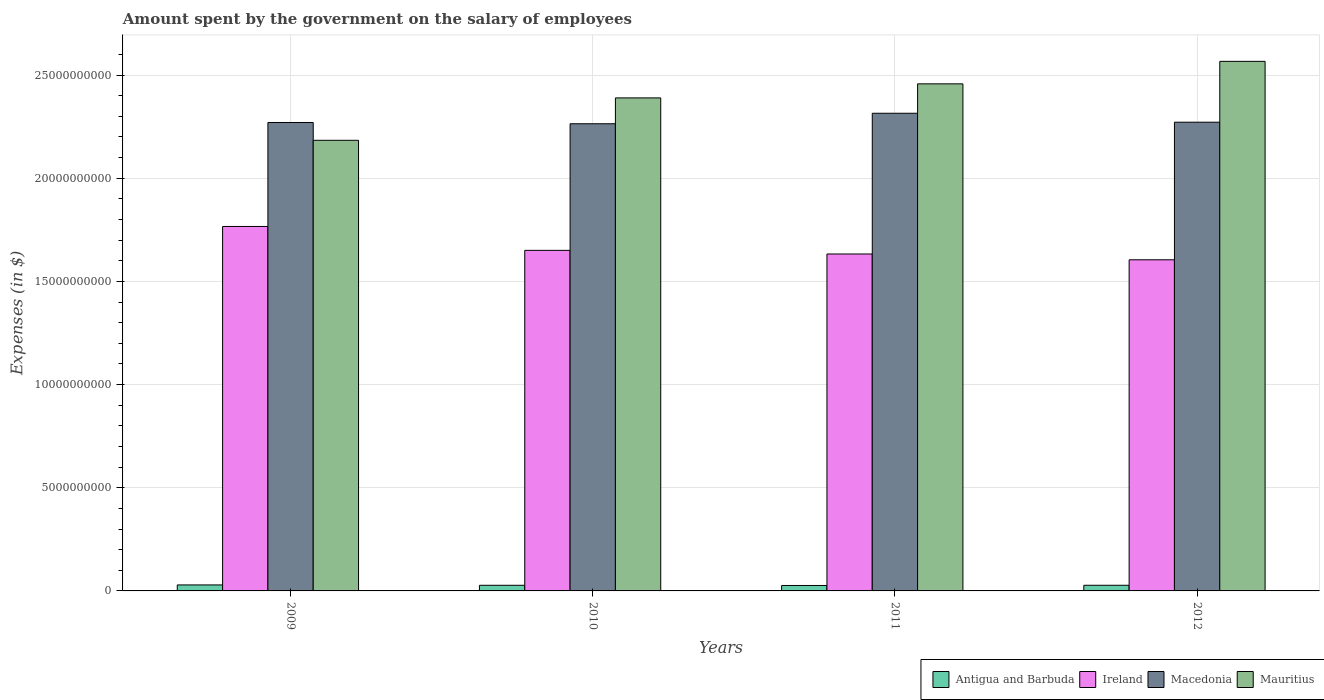Are the number of bars per tick equal to the number of legend labels?
Your response must be concise. Yes. How many bars are there on the 2nd tick from the left?
Ensure brevity in your answer.  4. How many bars are there on the 4th tick from the right?
Provide a succinct answer. 4. What is the label of the 4th group of bars from the left?
Make the answer very short. 2012. What is the amount spent on the salary of employees by the government in Mauritius in 2010?
Ensure brevity in your answer.  2.39e+1. Across all years, what is the maximum amount spent on the salary of employees by the government in Antigua and Barbuda?
Your answer should be very brief. 2.91e+08. Across all years, what is the minimum amount spent on the salary of employees by the government in Antigua and Barbuda?
Your answer should be compact. 2.64e+08. In which year was the amount spent on the salary of employees by the government in Macedonia minimum?
Your answer should be very brief. 2010. What is the total amount spent on the salary of employees by the government in Ireland in the graph?
Your response must be concise. 6.65e+1. What is the difference between the amount spent on the salary of employees by the government in Ireland in 2009 and that in 2011?
Provide a short and direct response. 1.33e+09. What is the difference between the amount spent on the salary of employees by the government in Ireland in 2010 and the amount spent on the salary of employees by the government in Macedonia in 2009?
Your response must be concise. -6.20e+09. What is the average amount spent on the salary of employees by the government in Antigua and Barbuda per year?
Your answer should be very brief. 2.75e+08. In the year 2009, what is the difference between the amount spent on the salary of employees by the government in Macedonia and amount spent on the salary of employees by the government in Mauritius?
Your response must be concise. 8.63e+08. In how many years, is the amount spent on the salary of employees by the government in Macedonia greater than 14000000000 $?
Ensure brevity in your answer.  4. What is the ratio of the amount spent on the salary of employees by the government in Macedonia in 2009 to that in 2011?
Your answer should be very brief. 0.98. Is the amount spent on the salary of employees by the government in Antigua and Barbuda in 2010 less than that in 2011?
Your response must be concise. No. What is the difference between the highest and the second highest amount spent on the salary of employees by the government in Antigua and Barbuda?
Give a very brief answer. 1.69e+07. What is the difference between the highest and the lowest amount spent on the salary of employees by the government in Ireland?
Keep it short and to the point. 1.61e+09. Is the sum of the amount spent on the salary of employees by the government in Ireland in 2010 and 2011 greater than the maximum amount spent on the salary of employees by the government in Macedonia across all years?
Ensure brevity in your answer.  Yes. What does the 4th bar from the left in 2012 represents?
Make the answer very short. Mauritius. What does the 1st bar from the right in 2009 represents?
Provide a short and direct response. Mauritius. Is it the case that in every year, the sum of the amount spent on the salary of employees by the government in Antigua and Barbuda and amount spent on the salary of employees by the government in Macedonia is greater than the amount spent on the salary of employees by the government in Ireland?
Provide a short and direct response. Yes. How many bars are there?
Ensure brevity in your answer.  16. What is the difference between two consecutive major ticks on the Y-axis?
Provide a succinct answer. 5.00e+09. Are the values on the major ticks of Y-axis written in scientific E-notation?
Your response must be concise. No. Does the graph contain any zero values?
Your response must be concise. No. How many legend labels are there?
Provide a succinct answer. 4. How are the legend labels stacked?
Your response must be concise. Horizontal. What is the title of the graph?
Your response must be concise. Amount spent by the government on the salary of employees. Does "Slovenia" appear as one of the legend labels in the graph?
Give a very brief answer. No. What is the label or title of the Y-axis?
Your answer should be very brief. Expenses (in $). What is the Expenses (in $) of Antigua and Barbuda in 2009?
Your answer should be very brief. 2.91e+08. What is the Expenses (in $) of Ireland in 2009?
Provide a succinct answer. 1.77e+1. What is the Expenses (in $) in Macedonia in 2009?
Offer a terse response. 2.27e+1. What is the Expenses (in $) of Mauritius in 2009?
Ensure brevity in your answer.  2.18e+1. What is the Expenses (in $) of Antigua and Barbuda in 2010?
Make the answer very short. 2.73e+08. What is the Expenses (in $) of Ireland in 2010?
Your response must be concise. 1.65e+1. What is the Expenses (in $) of Macedonia in 2010?
Ensure brevity in your answer.  2.26e+1. What is the Expenses (in $) of Mauritius in 2010?
Your answer should be compact. 2.39e+1. What is the Expenses (in $) of Antigua and Barbuda in 2011?
Ensure brevity in your answer.  2.64e+08. What is the Expenses (in $) in Ireland in 2011?
Give a very brief answer. 1.63e+1. What is the Expenses (in $) of Macedonia in 2011?
Provide a short and direct response. 2.31e+1. What is the Expenses (in $) in Mauritius in 2011?
Ensure brevity in your answer.  2.46e+1. What is the Expenses (in $) of Antigua and Barbuda in 2012?
Your response must be concise. 2.74e+08. What is the Expenses (in $) of Ireland in 2012?
Your answer should be compact. 1.60e+1. What is the Expenses (in $) of Macedonia in 2012?
Offer a very short reply. 2.27e+1. What is the Expenses (in $) of Mauritius in 2012?
Provide a short and direct response. 2.57e+1. Across all years, what is the maximum Expenses (in $) in Antigua and Barbuda?
Your answer should be very brief. 2.91e+08. Across all years, what is the maximum Expenses (in $) in Ireland?
Provide a short and direct response. 1.77e+1. Across all years, what is the maximum Expenses (in $) in Macedonia?
Keep it short and to the point. 2.31e+1. Across all years, what is the maximum Expenses (in $) of Mauritius?
Make the answer very short. 2.57e+1. Across all years, what is the minimum Expenses (in $) of Antigua and Barbuda?
Your answer should be very brief. 2.64e+08. Across all years, what is the minimum Expenses (in $) of Ireland?
Keep it short and to the point. 1.60e+1. Across all years, what is the minimum Expenses (in $) of Macedonia?
Provide a succinct answer. 2.26e+1. Across all years, what is the minimum Expenses (in $) of Mauritius?
Provide a succinct answer. 2.18e+1. What is the total Expenses (in $) in Antigua and Barbuda in the graph?
Offer a very short reply. 1.10e+09. What is the total Expenses (in $) of Ireland in the graph?
Provide a short and direct response. 6.65e+1. What is the total Expenses (in $) in Macedonia in the graph?
Ensure brevity in your answer.  9.12e+1. What is the total Expenses (in $) of Mauritius in the graph?
Your response must be concise. 9.60e+1. What is the difference between the Expenses (in $) of Antigua and Barbuda in 2009 and that in 2010?
Ensure brevity in your answer.  1.81e+07. What is the difference between the Expenses (in $) of Ireland in 2009 and that in 2010?
Offer a terse response. 1.16e+09. What is the difference between the Expenses (in $) in Macedonia in 2009 and that in 2010?
Provide a succinct answer. 6.10e+07. What is the difference between the Expenses (in $) of Mauritius in 2009 and that in 2010?
Your answer should be compact. -2.06e+09. What is the difference between the Expenses (in $) in Antigua and Barbuda in 2009 and that in 2011?
Your answer should be compact. 2.68e+07. What is the difference between the Expenses (in $) of Ireland in 2009 and that in 2011?
Your response must be concise. 1.33e+09. What is the difference between the Expenses (in $) in Macedonia in 2009 and that in 2011?
Make the answer very short. -4.48e+08. What is the difference between the Expenses (in $) in Mauritius in 2009 and that in 2011?
Your response must be concise. -2.74e+09. What is the difference between the Expenses (in $) of Antigua and Barbuda in 2009 and that in 2012?
Provide a succinct answer. 1.69e+07. What is the difference between the Expenses (in $) of Ireland in 2009 and that in 2012?
Give a very brief answer. 1.61e+09. What is the difference between the Expenses (in $) of Macedonia in 2009 and that in 2012?
Offer a terse response. -1.50e+07. What is the difference between the Expenses (in $) in Mauritius in 2009 and that in 2012?
Keep it short and to the point. -3.83e+09. What is the difference between the Expenses (in $) in Antigua and Barbuda in 2010 and that in 2011?
Your response must be concise. 8.70e+06. What is the difference between the Expenses (in $) of Ireland in 2010 and that in 2011?
Provide a short and direct response. 1.77e+08. What is the difference between the Expenses (in $) in Macedonia in 2010 and that in 2011?
Give a very brief answer. -5.09e+08. What is the difference between the Expenses (in $) in Mauritius in 2010 and that in 2011?
Give a very brief answer. -6.81e+08. What is the difference between the Expenses (in $) of Antigua and Barbuda in 2010 and that in 2012?
Provide a succinct answer. -1.20e+06. What is the difference between the Expenses (in $) of Ireland in 2010 and that in 2012?
Your answer should be compact. 4.57e+08. What is the difference between the Expenses (in $) of Macedonia in 2010 and that in 2012?
Offer a very short reply. -7.60e+07. What is the difference between the Expenses (in $) of Mauritius in 2010 and that in 2012?
Your answer should be very brief. -1.77e+09. What is the difference between the Expenses (in $) in Antigua and Barbuda in 2011 and that in 2012?
Your answer should be very brief. -9.90e+06. What is the difference between the Expenses (in $) in Ireland in 2011 and that in 2012?
Keep it short and to the point. 2.81e+08. What is the difference between the Expenses (in $) in Macedonia in 2011 and that in 2012?
Keep it short and to the point. 4.33e+08. What is the difference between the Expenses (in $) in Mauritius in 2011 and that in 2012?
Provide a short and direct response. -1.09e+09. What is the difference between the Expenses (in $) of Antigua and Barbuda in 2009 and the Expenses (in $) of Ireland in 2010?
Offer a terse response. -1.62e+1. What is the difference between the Expenses (in $) of Antigua and Barbuda in 2009 and the Expenses (in $) of Macedonia in 2010?
Make the answer very short. -2.23e+1. What is the difference between the Expenses (in $) of Antigua and Barbuda in 2009 and the Expenses (in $) of Mauritius in 2010?
Ensure brevity in your answer.  -2.36e+1. What is the difference between the Expenses (in $) of Ireland in 2009 and the Expenses (in $) of Macedonia in 2010?
Give a very brief answer. -4.98e+09. What is the difference between the Expenses (in $) in Ireland in 2009 and the Expenses (in $) in Mauritius in 2010?
Your answer should be compact. -6.23e+09. What is the difference between the Expenses (in $) of Macedonia in 2009 and the Expenses (in $) of Mauritius in 2010?
Make the answer very short. -1.19e+09. What is the difference between the Expenses (in $) in Antigua and Barbuda in 2009 and the Expenses (in $) in Ireland in 2011?
Offer a terse response. -1.60e+1. What is the difference between the Expenses (in $) in Antigua and Barbuda in 2009 and the Expenses (in $) in Macedonia in 2011?
Provide a succinct answer. -2.29e+1. What is the difference between the Expenses (in $) of Antigua and Barbuda in 2009 and the Expenses (in $) of Mauritius in 2011?
Your answer should be very brief. -2.43e+1. What is the difference between the Expenses (in $) of Ireland in 2009 and the Expenses (in $) of Macedonia in 2011?
Keep it short and to the point. -5.49e+09. What is the difference between the Expenses (in $) in Ireland in 2009 and the Expenses (in $) in Mauritius in 2011?
Provide a succinct answer. -6.91e+09. What is the difference between the Expenses (in $) in Macedonia in 2009 and the Expenses (in $) in Mauritius in 2011?
Provide a short and direct response. -1.87e+09. What is the difference between the Expenses (in $) in Antigua and Barbuda in 2009 and the Expenses (in $) in Ireland in 2012?
Your answer should be very brief. -1.58e+1. What is the difference between the Expenses (in $) of Antigua and Barbuda in 2009 and the Expenses (in $) of Macedonia in 2012?
Your response must be concise. -2.24e+1. What is the difference between the Expenses (in $) of Antigua and Barbuda in 2009 and the Expenses (in $) of Mauritius in 2012?
Make the answer very short. -2.54e+1. What is the difference between the Expenses (in $) of Ireland in 2009 and the Expenses (in $) of Macedonia in 2012?
Your answer should be very brief. -5.05e+09. What is the difference between the Expenses (in $) in Ireland in 2009 and the Expenses (in $) in Mauritius in 2012?
Make the answer very short. -8.00e+09. What is the difference between the Expenses (in $) of Macedonia in 2009 and the Expenses (in $) of Mauritius in 2012?
Ensure brevity in your answer.  -2.96e+09. What is the difference between the Expenses (in $) of Antigua and Barbuda in 2010 and the Expenses (in $) of Ireland in 2011?
Offer a terse response. -1.61e+1. What is the difference between the Expenses (in $) in Antigua and Barbuda in 2010 and the Expenses (in $) in Macedonia in 2011?
Your response must be concise. -2.29e+1. What is the difference between the Expenses (in $) of Antigua and Barbuda in 2010 and the Expenses (in $) of Mauritius in 2011?
Keep it short and to the point. -2.43e+1. What is the difference between the Expenses (in $) of Ireland in 2010 and the Expenses (in $) of Macedonia in 2011?
Provide a succinct answer. -6.64e+09. What is the difference between the Expenses (in $) of Ireland in 2010 and the Expenses (in $) of Mauritius in 2011?
Offer a very short reply. -8.07e+09. What is the difference between the Expenses (in $) in Macedonia in 2010 and the Expenses (in $) in Mauritius in 2011?
Your answer should be compact. -1.93e+09. What is the difference between the Expenses (in $) in Antigua and Barbuda in 2010 and the Expenses (in $) in Ireland in 2012?
Offer a very short reply. -1.58e+1. What is the difference between the Expenses (in $) in Antigua and Barbuda in 2010 and the Expenses (in $) in Macedonia in 2012?
Your response must be concise. -2.24e+1. What is the difference between the Expenses (in $) in Antigua and Barbuda in 2010 and the Expenses (in $) in Mauritius in 2012?
Make the answer very short. -2.54e+1. What is the difference between the Expenses (in $) of Ireland in 2010 and the Expenses (in $) of Macedonia in 2012?
Provide a succinct answer. -6.21e+09. What is the difference between the Expenses (in $) of Ireland in 2010 and the Expenses (in $) of Mauritius in 2012?
Your answer should be compact. -9.16e+09. What is the difference between the Expenses (in $) in Macedonia in 2010 and the Expenses (in $) in Mauritius in 2012?
Ensure brevity in your answer.  -3.02e+09. What is the difference between the Expenses (in $) of Antigua and Barbuda in 2011 and the Expenses (in $) of Ireland in 2012?
Offer a terse response. -1.58e+1. What is the difference between the Expenses (in $) of Antigua and Barbuda in 2011 and the Expenses (in $) of Macedonia in 2012?
Provide a succinct answer. -2.25e+1. What is the difference between the Expenses (in $) in Antigua and Barbuda in 2011 and the Expenses (in $) in Mauritius in 2012?
Provide a succinct answer. -2.54e+1. What is the difference between the Expenses (in $) of Ireland in 2011 and the Expenses (in $) of Macedonia in 2012?
Your answer should be compact. -6.39e+09. What is the difference between the Expenses (in $) in Ireland in 2011 and the Expenses (in $) in Mauritius in 2012?
Make the answer very short. -9.34e+09. What is the difference between the Expenses (in $) of Macedonia in 2011 and the Expenses (in $) of Mauritius in 2012?
Your response must be concise. -2.52e+09. What is the average Expenses (in $) in Antigua and Barbuda per year?
Your response must be concise. 2.75e+08. What is the average Expenses (in $) of Ireland per year?
Provide a short and direct response. 1.66e+1. What is the average Expenses (in $) of Macedonia per year?
Your answer should be compact. 2.28e+1. What is the average Expenses (in $) of Mauritius per year?
Keep it short and to the point. 2.40e+1. In the year 2009, what is the difference between the Expenses (in $) of Antigua and Barbuda and Expenses (in $) of Ireland?
Offer a terse response. -1.74e+1. In the year 2009, what is the difference between the Expenses (in $) in Antigua and Barbuda and Expenses (in $) in Macedonia?
Your answer should be very brief. -2.24e+1. In the year 2009, what is the difference between the Expenses (in $) in Antigua and Barbuda and Expenses (in $) in Mauritius?
Offer a terse response. -2.15e+1. In the year 2009, what is the difference between the Expenses (in $) in Ireland and Expenses (in $) in Macedonia?
Your answer should be very brief. -5.04e+09. In the year 2009, what is the difference between the Expenses (in $) in Ireland and Expenses (in $) in Mauritius?
Keep it short and to the point. -4.17e+09. In the year 2009, what is the difference between the Expenses (in $) of Macedonia and Expenses (in $) of Mauritius?
Give a very brief answer. 8.63e+08. In the year 2010, what is the difference between the Expenses (in $) of Antigua and Barbuda and Expenses (in $) of Ireland?
Your response must be concise. -1.62e+1. In the year 2010, what is the difference between the Expenses (in $) in Antigua and Barbuda and Expenses (in $) in Macedonia?
Your response must be concise. -2.24e+1. In the year 2010, what is the difference between the Expenses (in $) of Antigua and Barbuda and Expenses (in $) of Mauritius?
Offer a terse response. -2.36e+1. In the year 2010, what is the difference between the Expenses (in $) in Ireland and Expenses (in $) in Macedonia?
Offer a very short reply. -6.13e+09. In the year 2010, what is the difference between the Expenses (in $) in Ireland and Expenses (in $) in Mauritius?
Ensure brevity in your answer.  -7.39e+09. In the year 2010, what is the difference between the Expenses (in $) of Macedonia and Expenses (in $) of Mauritius?
Your answer should be very brief. -1.25e+09. In the year 2011, what is the difference between the Expenses (in $) of Antigua and Barbuda and Expenses (in $) of Ireland?
Make the answer very short. -1.61e+1. In the year 2011, what is the difference between the Expenses (in $) in Antigua and Barbuda and Expenses (in $) in Macedonia?
Keep it short and to the point. -2.29e+1. In the year 2011, what is the difference between the Expenses (in $) of Antigua and Barbuda and Expenses (in $) of Mauritius?
Your answer should be very brief. -2.43e+1. In the year 2011, what is the difference between the Expenses (in $) of Ireland and Expenses (in $) of Macedonia?
Keep it short and to the point. -6.82e+09. In the year 2011, what is the difference between the Expenses (in $) of Ireland and Expenses (in $) of Mauritius?
Give a very brief answer. -8.25e+09. In the year 2011, what is the difference between the Expenses (in $) in Macedonia and Expenses (in $) in Mauritius?
Keep it short and to the point. -1.43e+09. In the year 2012, what is the difference between the Expenses (in $) in Antigua and Barbuda and Expenses (in $) in Ireland?
Ensure brevity in your answer.  -1.58e+1. In the year 2012, what is the difference between the Expenses (in $) of Antigua and Barbuda and Expenses (in $) of Macedonia?
Keep it short and to the point. -2.24e+1. In the year 2012, what is the difference between the Expenses (in $) of Antigua and Barbuda and Expenses (in $) of Mauritius?
Provide a short and direct response. -2.54e+1. In the year 2012, what is the difference between the Expenses (in $) in Ireland and Expenses (in $) in Macedonia?
Keep it short and to the point. -6.67e+09. In the year 2012, what is the difference between the Expenses (in $) in Ireland and Expenses (in $) in Mauritius?
Make the answer very short. -9.62e+09. In the year 2012, what is the difference between the Expenses (in $) in Macedonia and Expenses (in $) in Mauritius?
Offer a terse response. -2.95e+09. What is the ratio of the Expenses (in $) of Antigua and Barbuda in 2009 to that in 2010?
Your answer should be compact. 1.07. What is the ratio of the Expenses (in $) in Ireland in 2009 to that in 2010?
Make the answer very short. 1.07. What is the ratio of the Expenses (in $) in Macedonia in 2009 to that in 2010?
Your response must be concise. 1. What is the ratio of the Expenses (in $) of Mauritius in 2009 to that in 2010?
Offer a very short reply. 0.91. What is the ratio of the Expenses (in $) in Antigua and Barbuda in 2009 to that in 2011?
Your answer should be compact. 1.1. What is the ratio of the Expenses (in $) in Ireland in 2009 to that in 2011?
Ensure brevity in your answer.  1.08. What is the ratio of the Expenses (in $) of Macedonia in 2009 to that in 2011?
Ensure brevity in your answer.  0.98. What is the ratio of the Expenses (in $) in Mauritius in 2009 to that in 2011?
Keep it short and to the point. 0.89. What is the ratio of the Expenses (in $) of Antigua and Barbuda in 2009 to that in 2012?
Make the answer very short. 1.06. What is the ratio of the Expenses (in $) in Ireland in 2009 to that in 2012?
Make the answer very short. 1.1. What is the ratio of the Expenses (in $) in Mauritius in 2009 to that in 2012?
Your response must be concise. 0.85. What is the ratio of the Expenses (in $) in Antigua and Barbuda in 2010 to that in 2011?
Your response must be concise. 1.03. What is the ratio of the Expenses (in $) of Ireland in 2010 to that in 2011?
Make the answer very short. 1.01. What is the ratio of the Expenses (in $) of Mauritius in 2010 to that in 2011?
Your response must be concise. 0.97. What is the ratio of the Expenses (in $) in Ireland in 2010 to that in 2012?
Provide a short and direct response. 1.03. What is the ratio of the Expenses (in $) in Mauritius in 2010 to that in 2012?
Provide a short and direct response. 0.93. What is the ratio of the Expenses (in $) in Antigua and Barbuda in 2011 to that in 2012?
Offer a terse response. 0.96. What is the ratio of the Expenses (in $) in Ireland in 2011 to that in 2012?
Keep it short and to the point. 1.02. What is the ratio of the Expenses (in $) in Macedonia in 2011 to that in 2012?
Offer a terse response. 1.02. What is the ratio of the Expenses (in $) in Mauritius in 2011 to that in 2012?
Your answer should be very brief. 0.96. What is the difference between the highest and the second highest Expenses (in $) in Antigua and Barbuda?
Your answer should be compact. 1.69e+07. What is the difference between the highest and the second highest Expenses (in $) of Ireland?
Keep it short and to the point. 1.16e+09. What is the difference between the highest and the second highest Expenses (in $) of Macedonia?
Provide a short and direct response. 4.33e+08. What is the difference between the highest and the second highest Expenses (in $) of Mauritius?
Offer a very short reply. 1.09e+09. What is the difference between the highest and the lowest Expenses (in $) of Antigua and Barbuda?
Provide a succinct answer. 2.68e+07. What is the difference between the highest and the lowest Expenses (in $) in Ireland?
Provide a succinct answer. 1.61e+09. What is the difference between the highest and the lowest Expenses (in $) of Macedonia?
Make the answer very short. 5.09e+08. What is the difference between the highest and the lowest Expenses (in $) of Mauritius?
Offer a terse response. 3.83e+09. 